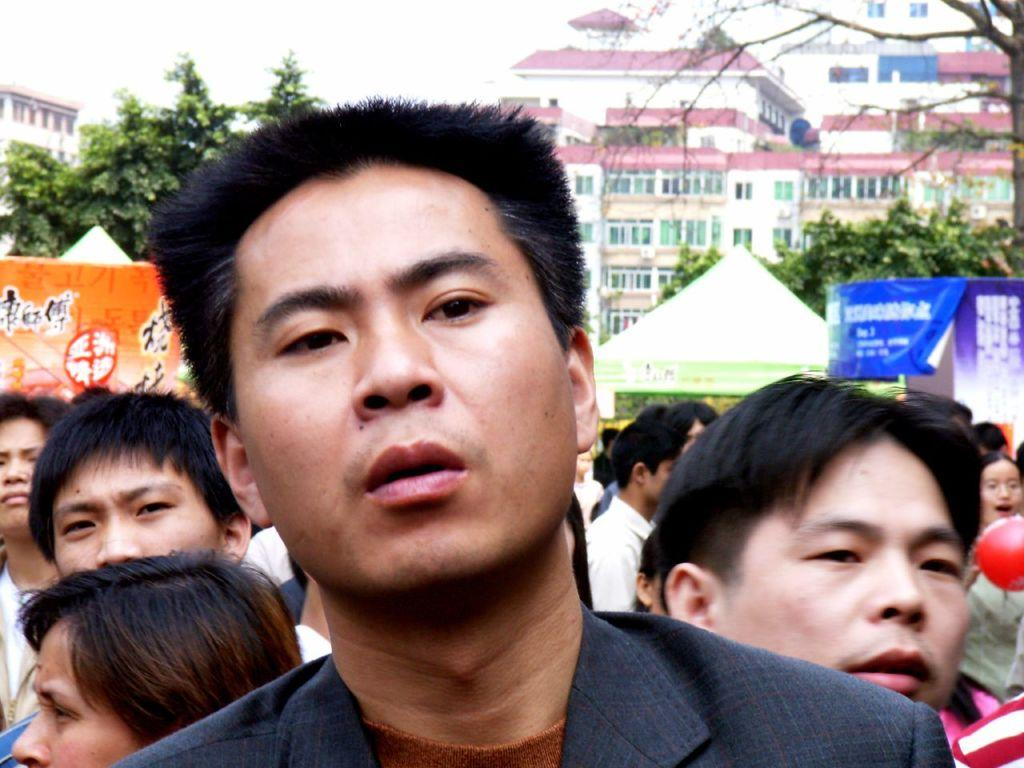What can be seen in the image involving a large number of people? There is a group of people in the image. What object is present in the image that is typically filled with air? There is a balloon in the image. What can be seen in the background of the image that might indicate a special event or gathering? There are banners in the background of the image. What type of natural scenery is visible in the background of the image? There are trees in the background of the image. What type of man-made structures can be seen in the background of the image? There are buildings in the background of the image. What type of machine can be seen in the image? There is no machine present in the image. What color is the notebook on the table in the image? There is no notebook present in the image. 